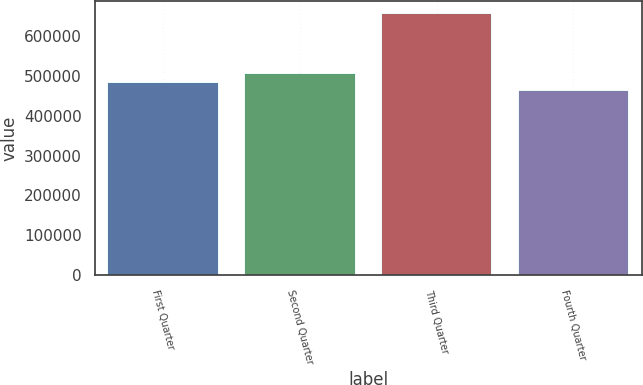<chart> <loc_0><loc_0><loc_500><loc_500><bar_chart><fcel>First Quarter<fcel>Second Quarter<fcel>Third Quarter<fcel>Fourth Quarter<nl><fcel>481606<fcel>504252<fcel>654599<fcel>462384<nl></chart> 